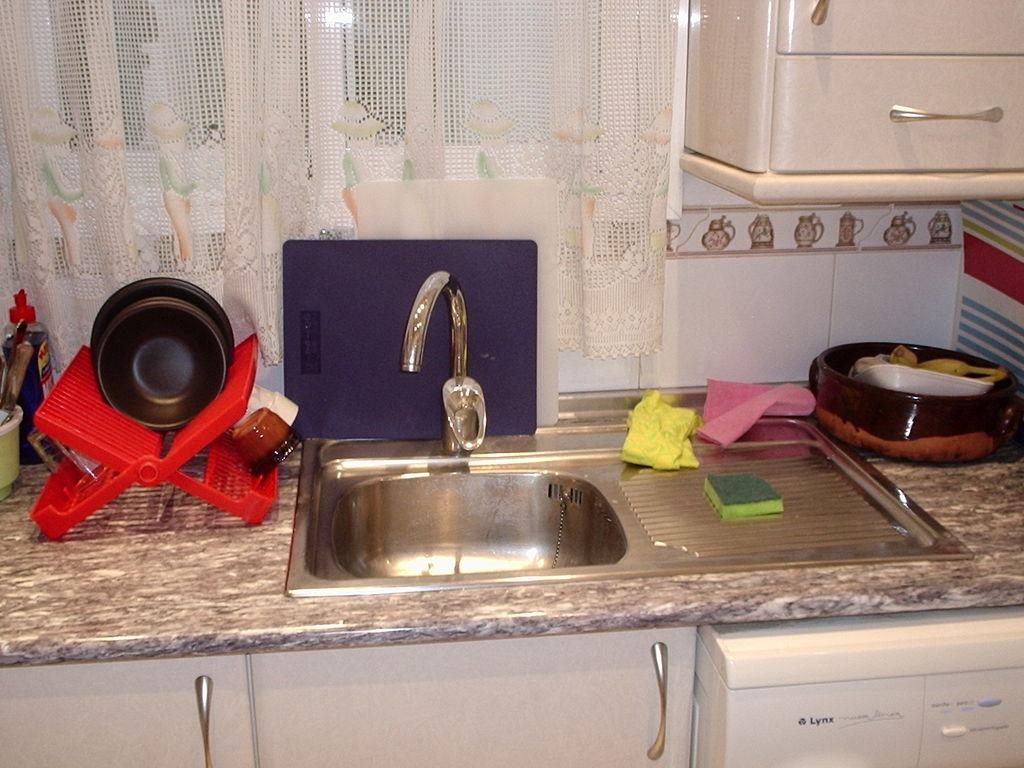<image>
Share a concise interpretation of the image provided. a sponge lies on a sink which rests over a Lynx dishwasher 